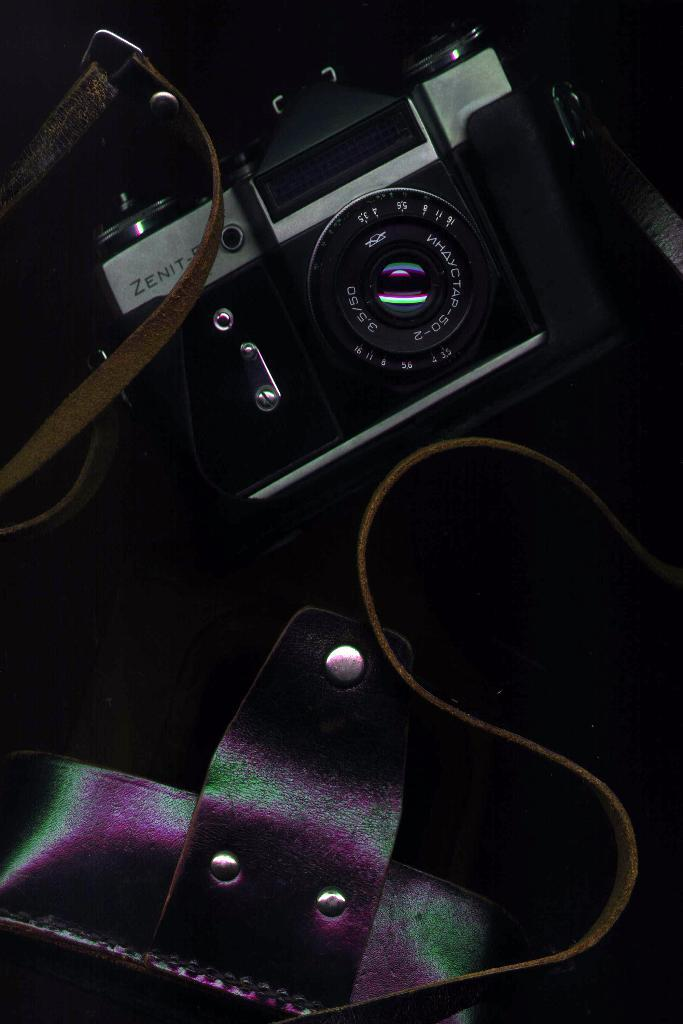What is the main subject of the image? The main subject of the image is a camera. Can you describe any other objects present in the image? Yes, there are a few objects in the image. Can you hear the camera crying in the image? No, cameras do not have the ability to cry, and there is no indication of any crying sound in the image. 